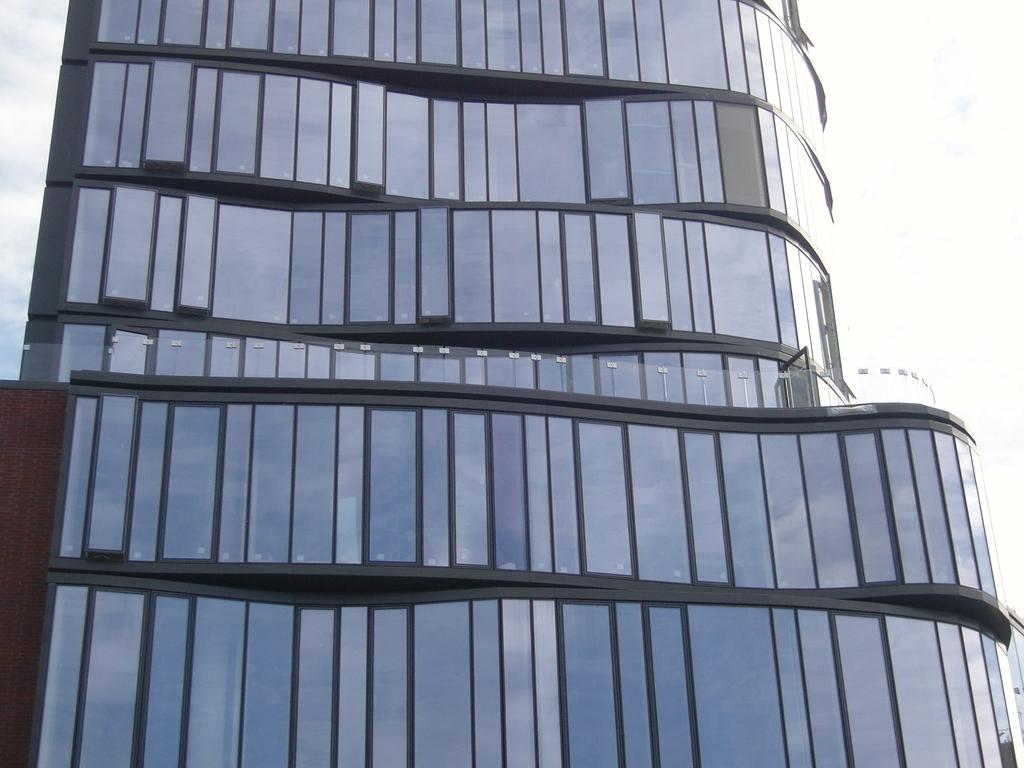What type of building is depicted in the image? There is a glass building in the image. What can be observed about the sky in the image? The sky is white in color. What type of oven is visible in the image? There is no oven present in the image. 